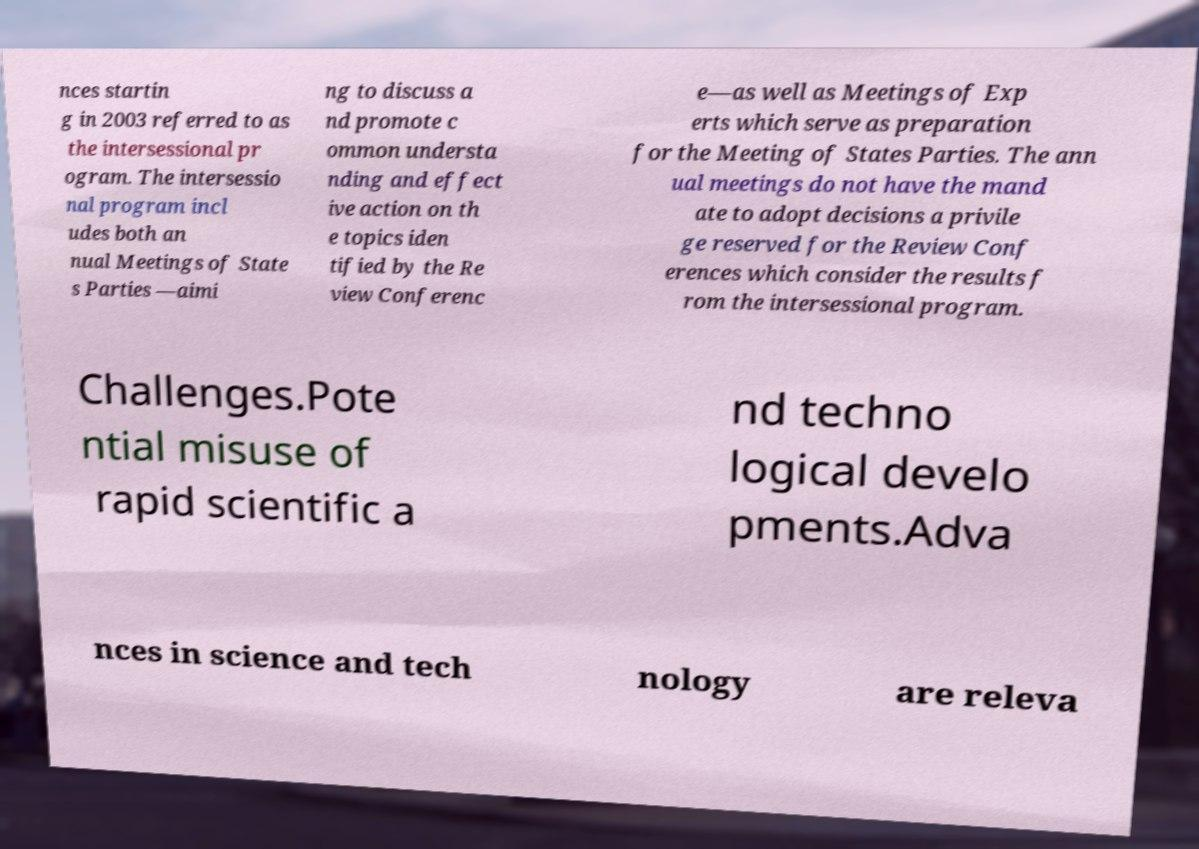Can you read and provide the text displayed in the image?This photo seems to have some interesting text. Can you extract and type it out for me? nces startin g in 2003 referred to as the intersessional pr ogram. The intersessio nal program incl udes both an nual Meetings of State s Parties —aimi ng to discuss a nd promote c ommon understa nding and effect ive action on th e topics iden tified by the Re view Conferenc e—as well as Meetings of Exp erts which serve as preparation for the Meeting of States Parties. The ann ual meetings do not have the mand ate to adopt decisions a privile ge reserved for the Review Conf erences which consider the results f rom the intersessional program. Challenges.Pote ntial misuse of rapid scientific a nd techno logical develo pments.Adva nces in science and tech nology are releva 